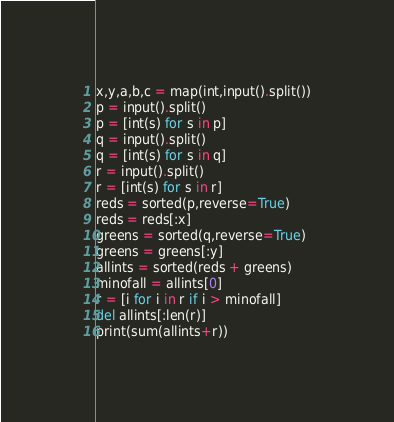<code> <loc_0><loc_0><loc_500><loc_500><_Python_>x,y,a,b,c = map(int,input().split())
p = input().split()
p = [int(s) for s in p]
q = input().split()
q = [int(s) for s in q]
r = input().split()
r = [int(s) for s in r]
reds = sorted(p,reverse=True)
reds = reds[:x]
greens = sorted(q,reverse=True)
greens = greens[:y]
allints = sorted(reds + greens)
minofall = allints[0]
r = [i for i in r if i > minofall]
del allints[:len(r)]
print(sum(allints+r))
</code> 